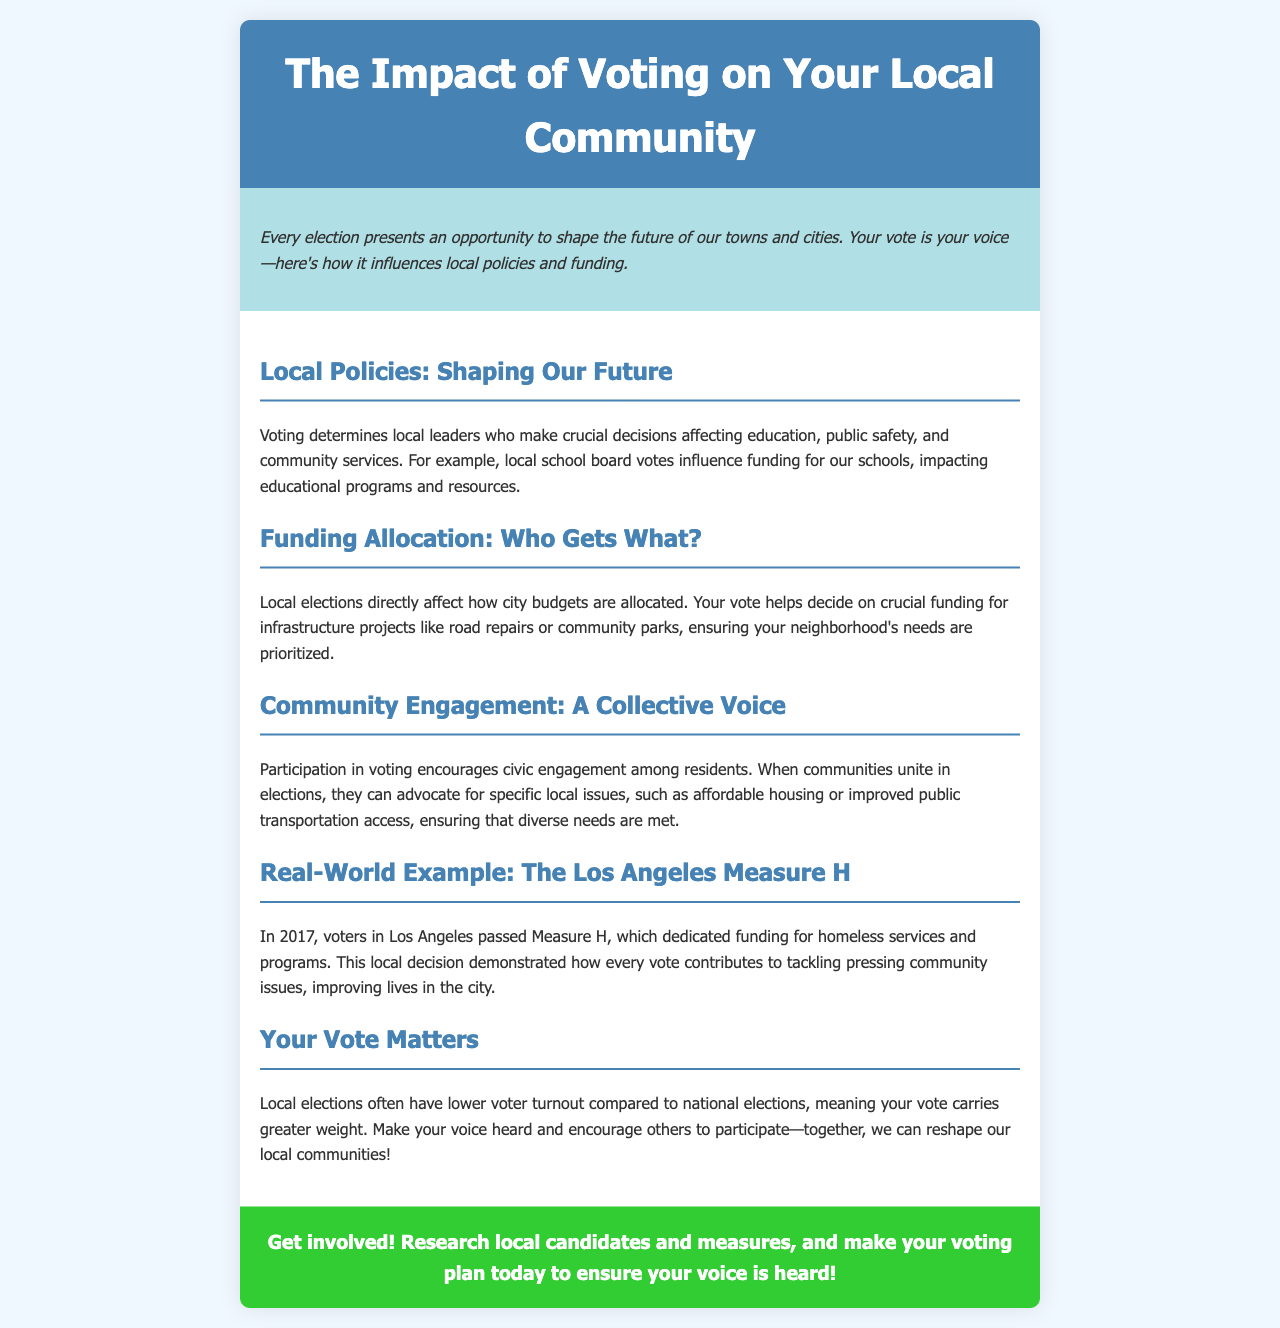What does voting shape? Voting influences local policies and funding that affect the community's future.
Answer: Local policies and funding What was passed in 2017 in Los Angeles? Measure H was a significant local funding initiative passed by voters in Los Angeles.
Answer: Measure H What do local elections determine? Local elections determine local leaders who make crucial decisions affecting various community aspects.
Answer: Local leaders What is one issue that voting can help advocate for? Voting encourages communities to advocate for specific local issues, such as affordable housing.
Answer: Affordable housing Why does your vote carry more weight in local elections? Local elections often have lower voter turnout, making individual votes more impactful.
Answer: Lower voter turnout 